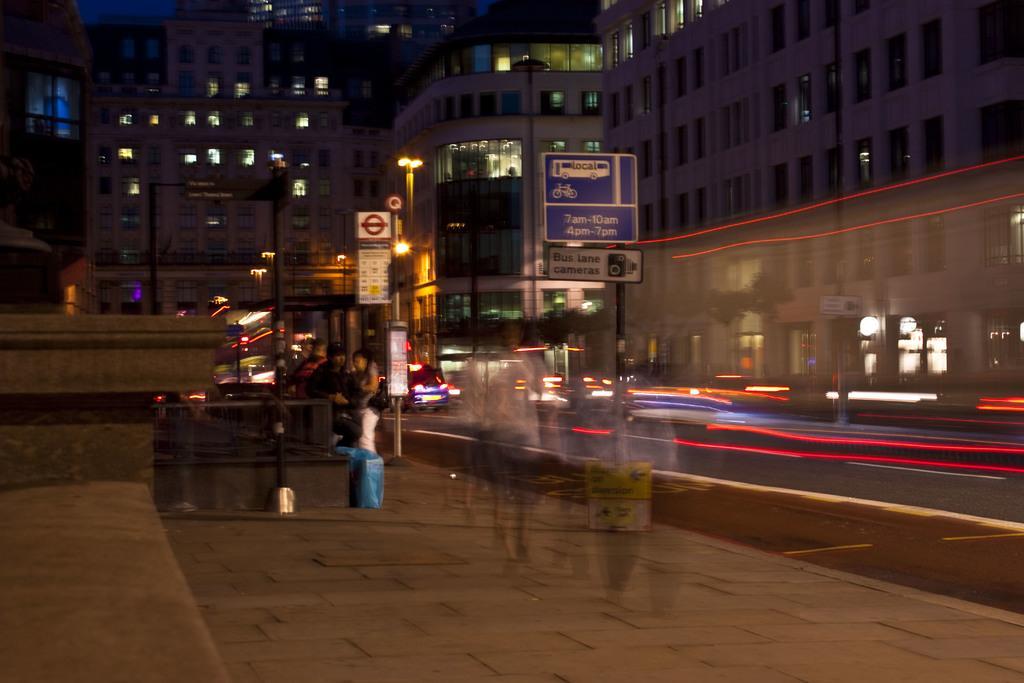Describe this image in one or two sentences. This is the street view of a city, in this image there are a few cars passing on the road and there are sign boards on the pavement and there are two people standing on the pavement, in the background of the image there are buildings. 